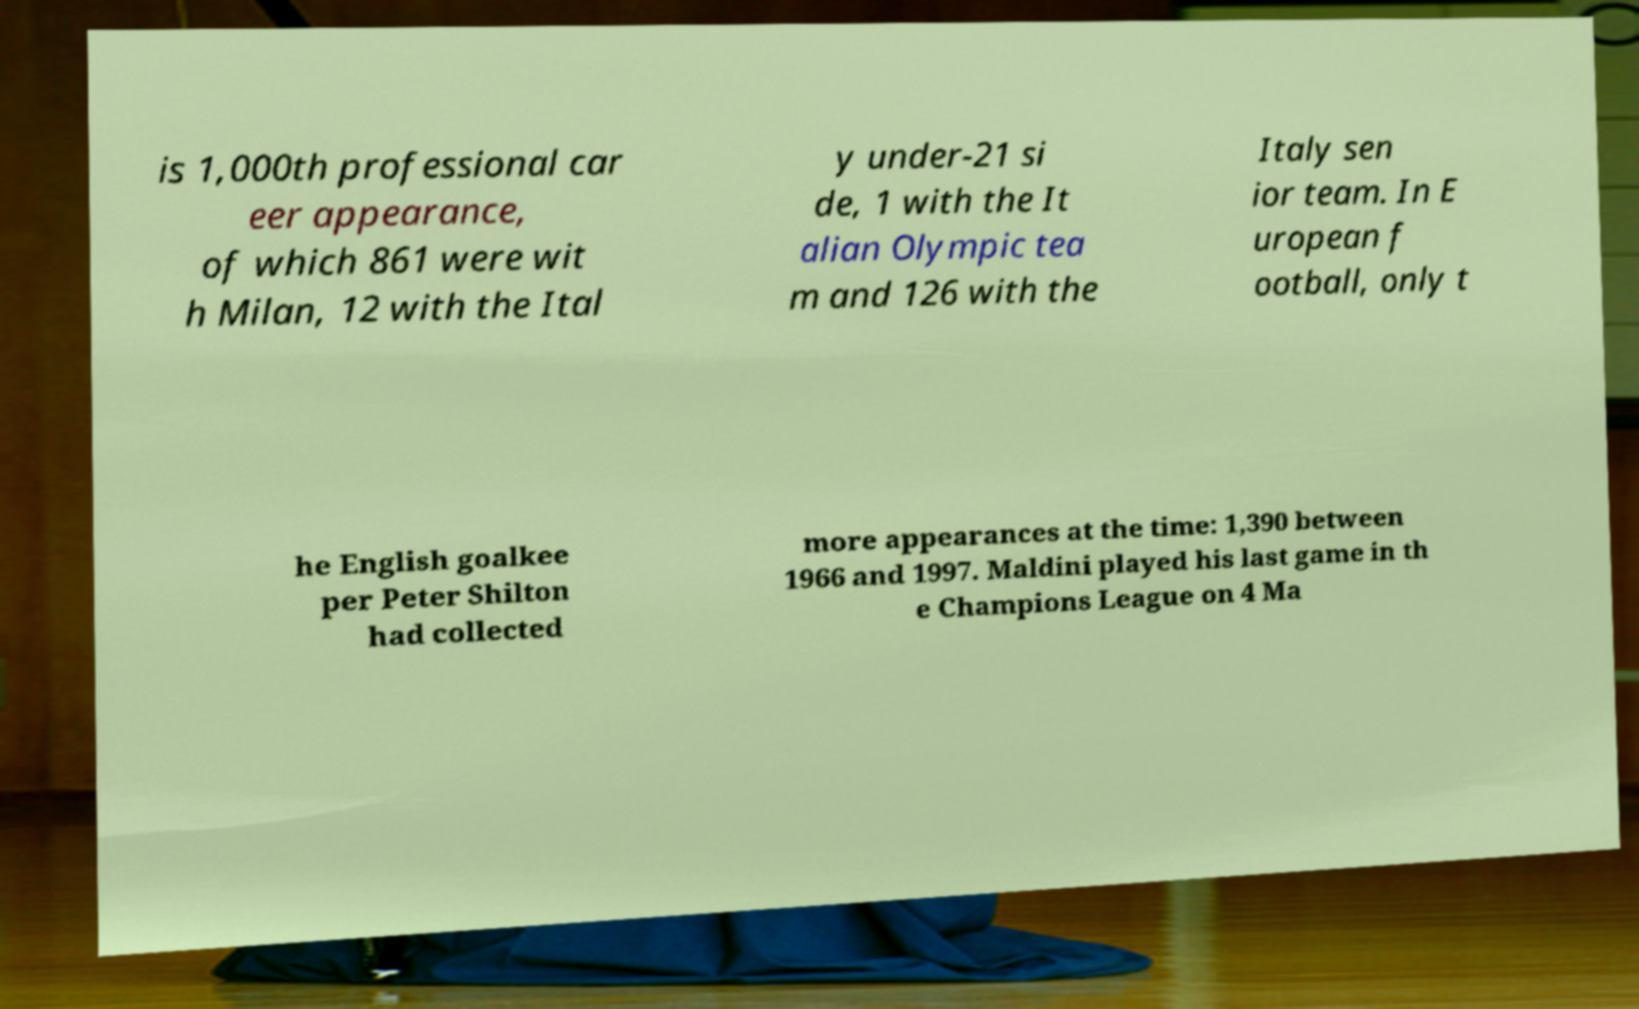For documentation purposes, I need the text within this image transcribed. Could you provide that? is 1,000th professional car eer appearance, of which 861 were wit h Milan, 12 with the Ital y under-21 si de, 1 with the It alian Olympic tea m and 126 with the Italy sen ior team. In E uropean f ootball, only t he English goalkee per Peter Shilton had collected more appearances at the time: 1,390 between 1966 and 1997. Maldini played his last game in th e Champions League on 4 Ma 